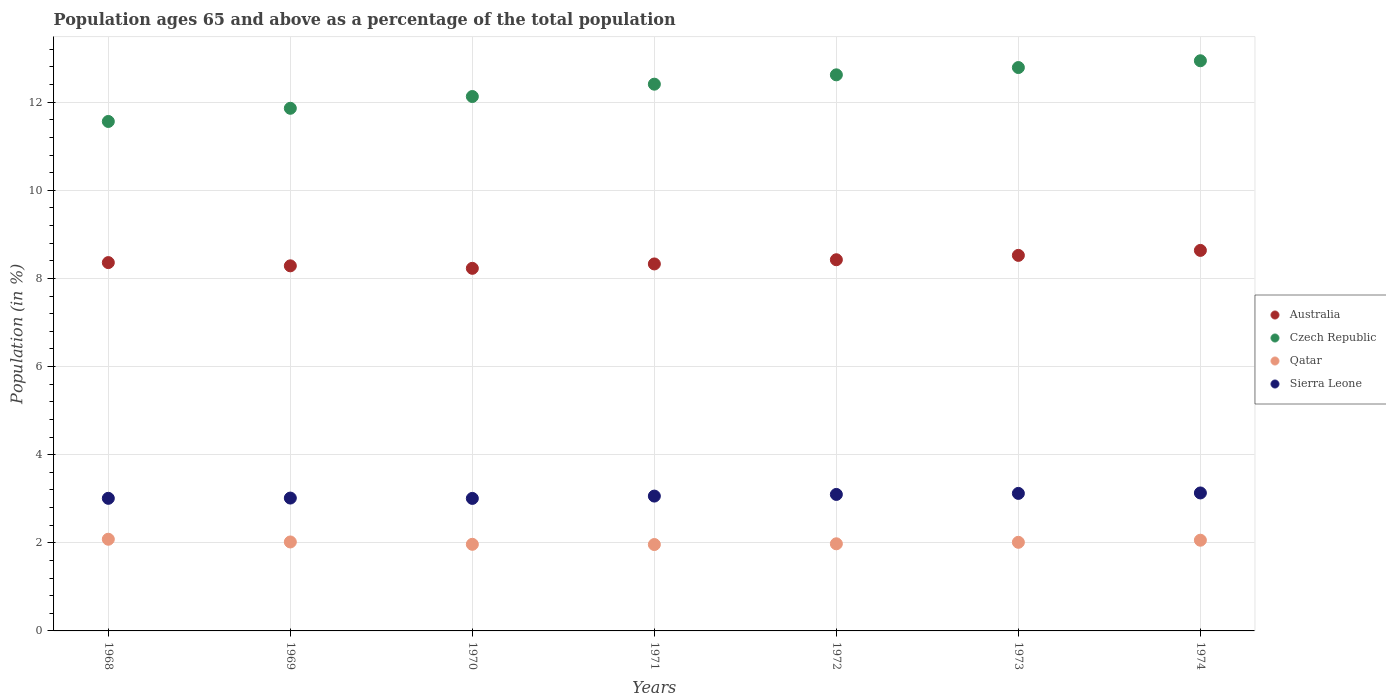Is the number of dotlines equal to the number of legend labels?
Offer a very short reply. Yes. What is the percentage of the population ages 65 and above in Sierra Leone in 1972?
Offer a terse response. 3.1. Across all years, what is the maximum percentage of the population ages 65 and above in Qatar?
Offer a terse response. 2.08. Across all years, what is the minimum percentage of the population ages 65 and above in Czech Republic?
Provide a succinct answer. 11.56. In which year was the percentage of the population ages 65 and above in Qatar maximum?
Provide a succinct answer. 1968. In which year was the percentage of the population ages 65 and above in Czech Republic minimum?
Offer a terse response. 1968. What is the total percentage of the population ages 65 and above in Sierra Leone in the graph?
Offer a very short reply. 21.44. What is the difference between the percentage of the population ages 65 and above in Australia in 1969 and that in 1973?
Your response must be concise. -0.24. What is the difference between the percentage of the population ages 65 and above in Qatar in 1972 and the percentage of the population ages 65 and above in Australia in 1968?
Make the answer very short. -6.38. What is the average percentage of the population ages 65 and above in Qatar per year?
Make the answer very short. 2.01. In the year 1968, what is the difference between the percentage of the population ages 65 and above in Qatar and percentage of the population ages 65 and above in Australia?
Your response must be concise. -6.28. In how many years, is the percentage of the population ages 65 and above in Sierra Leone greater than 11.2?
Offer a terse response. 0. What is the ratio of the percentage of the population ages 65 and above in Sierra Leone in 1968 to that in 1973?
Your response must be concise. 0.96. Is the percentage of the population ages 65 and above in Qatar in 1971 less than that in 1972?
Make the answer very short. Yes. Is the difference between the percentage of the population ages 65 and above in Qatar in 1969 and 1972 greater than the difference between the percentage of the population ages 65 and above in Australia in 1969 and 1972?
Your answer should be very brief. Yes. What is the difference between the highest and the second highest percentage of the population ages 65 and above in Australia?
Provide a short and direct response. 0.11. What is the difference between the highest and the lowest percentage of the population ages 65 and above in Qatar?
Offer a very short reply. 0.12. In how many years, is the percentage of the population ages 65 and above in Australia greater than the average percentage of the population ages 65 and above in Australia taken over all years?
Provide a short and direct response. 3. Is it the case that in every year, the sum of the percentage of the population ages 65 and above in Czech Republic and percentage of the population ages 65 and above in Qatar  is greater than the sum of percentage of the population ages 65 and above in Australia and percentage of the population ages 65 and above in Sierra Leone?
Your answer should be compact. No. Is it the case that in every year, the sum of the percentage of the population ages 65 and above in Sierra Leone and percentage of the population ages 65 and above in Qatar  is greater than the percentage of the population ages 65 and above in Czech Republic?
Your response must be concise. No. Does the percentage of the population ages 65 and above in Qatar monotonically increase over the years?
Your answer should be very brief. No. Does the graph contain any zero values?
Your answer should be compact. No. How many legend labels are there?
Give a very brief answer. 4. How are the legend labels stacked?
Provide a succinct answer. Vertical. What is the title of the graph?
Make the answer very short. Population ages 65 and above as a percentage of the total population. Does "Latin America(all income levels)" appear as one of the legend labels in the graph?
Offer a terse response. No. What is the Population (in %) in Australia in 1968?
Give a very brief answer. 8.36. What is the Population (in %) of Czech Republic in 1968?
Ensure brevity in your answer.  11.56. What is the Population (in %) in Qatar in 1968?
Your answer should be compact. 2.08. What is the Population (in %) in Sierra Leone in 1968?
Give a very brief answer. 3.01. What is the Population (in %) of Australia in 1969?
Ensure brevity in your answer.  8.29. What is the Population (in %) in Czech Republic in 1969?
Your response must be concise. 11.86. What is the Population (in %) in Qatar in 1969?
Keep it short and to the point. 2.02. What is the Population (in %) in Sierra Leone in 1969?
Your answer should be very brief. 3.02. What is the Population (in %) in Australia in 1970?
Your response must be concise. 8.23. What is the Population (in %) of Czech Republic in 1970?
Keep it short and to the point. 12.13. What is the Population (in %) of Qatar in 1970?
Your response must be concise. 1.97. What is the Population (in %) in Sierra Leone in 1970?
Make the answer very short. 3.01. What is the Population (in %) in Australia in 1971?
Offer a terse response. 8.33. What is the Population (in %) of Czech Republic in 1971?
Keep it short and to the point. 12.41. What is the Population (in %) in Qatar in 1971?
Your answer should be compact. 1.96. What is the Population (in %) of Sierra Leone in 1971?
Make the answer very short. 3.06. What is the Population (in %) in Australia in 1972?
Make the answer very short. 8.42. What is the Population (in %) in Czech Republic in 1972?
Give a very brief answer. 12.62. What is the Population (in %) in Qatar in 1972?
Your answer should be compact. 1.98. What is the Population (in %) in Sierra Leone in 1972?
Ensure brevity in your answer.  3.1. What is the Population (in %) in Australia in 1973?
Give a very brief answer. 8.52. What is the Population (in %) of Czech Republic in 1973?
Keep it short and to the point. 12.79. What is the Population (in %) in Qatar in 1973?
Ensure brevity in your answer.  2.01. What is the Population (in %) in Sierra Leone in 1973?
Ensure brevity in your answer.  3.12. What is the Population (in %) of Australia in 1974?
Offer a very short reply. 8.64. What is the Population (in %) in Czech Republic in 1974?
Your answer should be very brief. 12.94. What is the Population (in %) in Qatar in 1974?
Your answer should be compact. 2.06. What is the Population (in %) of Sierra Leone in 1974?
Your response must be concise. 3.13. Across all years, what is the maximum Population (in %) of Australia?
Give a very brief answer. 8.64. Across all years, what is the maximum Population (in %) of Czech Republic?
Give a very brief answer. 12.94. Across all years, what is the maximum Population (in %) in Qatar?
Provide a short and direct response. 2.08. Across all years, what is the maximum Population (in %) of Sierra Leone?
Give a very brief answer. 3.13. Across all years, what is the minimum Population (in %) of Australia?
Give a very brief answer. 8.23. Across all years, what is the minimum Population (in %) in Czech Republic?
Your answer should be very brief. 11.56. Across all years, what is the minimum Population (in %) in Qatar?
Your answer should be compact. 1.96. Across all years, what is the minimum Population (in %) in Sierra Leone?
Provide a succinct answer. 3.01. What is the total Population (in %) in Australia in the graph?
Make the answer very short. 58.79. What is the total Population (in %) of Czech Republic in the graph?
Offer a very short reply. 86.31. What is the total Population (in %) in Qatar in the graph?
Offer a very short reply. 14.07. What is the total Population (in %) in Sierra Leone in the graph?
Your answer should be very brief. 21.44. What is the difference between the Population (in %) in Australia in 1968 and that in 1969?
Ensure brevity in your answer.  0.07. What is the difference between the Population (in %) in Czech Republic in 1968 and that in 1969?
Your answer should be very brief. -0.3. What is the difference between the Population (in %) in Qatar in 1968 and that in 1969?
Your answer should be very brief. 0.06. What is the difference between the Population (in %) in Sierra Leone in 1968 and that in 1969?
Make the answer very short. -0.01. What is the difference between the Population (in %) of Australia in 1968 and that in 1970?
Make the answer very short. 0.13. What is the difference between the Population (in %) in Czech Republic in 1968 and that in 1970?
Provide a succinct answer. -0.57. What is the difference between the Population (in %) in Qatar in 1968 and that in 1970?
Provide a short and direct response. 0.12. What is the difference between the Population (in %) in Sierra Leone in 1968 and that in 1970?
Offer a very short reply. 0. What is the difference between the Population (in %) in Australia in 1968 and that in 1971?
Offer a very short reply. 0.03. What is the difference between the Population (in %) of Czech Republic in 1968 and that in 1971?
Your response must be concise. -0.85. What is the difference between the Population (in %) of Qatar in 1968 and that in 1971?
Provide a short and direct response. 0.12. What is the difference between the Population (in %) of Sierra Leone in 1968 and that in 1971?
Give a very brief answer. -0.05. What is the difference between the Population (in %) in Australia in 1968 and that in 1972?
Make the answer very short. -0.06. What is the difference between the Population (in %) of Czech Republic in 1968 and that in 1972?
Your answer should be very brief. -1.06. What is the difference between the Population (in %) of Qatar in 1968 and that in 1972?
Your response must be concise. 0.1. What is the difference between the Population (in %) in Sierra Leone in 1968 and that in 1972?
Give a very brief answer. -0.09. What is the difference between the Population (in %) of Australia in 1968 and that in 1973?
Provide a succinct answer. -0.16. What is the difference between the Population (in %) in Czech Republic in 1968 and that in 1973?
Keep it short and to the point. -1.22. What is the difference between the Population (in %) of Qatar in 1968 and that in 1973?
Make the answer very short. 0.07. What is the difference between the Population (in %) of Sierra Leone in 1968 and that in 1973?
Your answer should be very brief. -0.11. What is the difference between the Population (in %) in Australia in 1968 and that in 1974?
Give a very brief answer. -0.28. What is the difference between the Population (in %) in Czech Republic in 1968 and that in 1974?
Provide a succinct answer. -1.38. What is the difference between the Population (in %) of Qatar in 1968 and that in 1974?
Offer a very short reply. 0.02. What is the difference between the Population (in %) in Sierra Leone in 1968 and that in 1974?
Keep it short and to the point. -0.12. What is the difference between the Population (in %) in Australia in 1969 and that in 1970?
Make the answer very short. 0.06. What is the difference between the Population (in %) in Czech Republic in 1969 and that in 1970?
Your answer should be very brief. -0.27. What is the difference between the Population (in %) of Qatar in 1969 and that in 1970?
Make the answer very short. 0.05. What is the difference between the Population (in %) of Sierra Leone in 1969 and that in 1970?
Your answer should be very brief. 0.01. What is the difference between the Population (in %) in Australia in 1969 and that in 1971?
Make the answer very short. -0.04. What is the difference between the Population (in %) of Czech Republic in 1969 and that in 1971?
Keep it short and to the point. -0.55. What is the difference between the Population (in %) of Qatar in 1969 and that in 1971?
Keep it short and to the point. 0.06. What is the difference between the Population (in %) of Sierra Leone in 1969 and that in 1971?
Provide a succinct answer. -0.04. What is the difference between the Population (in %) of Australia in 1969 and that in 1972?
Offer a very short reply. -0.14. What is the difference between the Population (in %) of Czech Republic in 1969 and that in 1972?
Offer a very short reply. -0.76. What is the difference between the Population (in %) in Qatar in 1969 and that in 1972?
Your answer should be very brief. 0.04. What is the difference between the Population (in %) of Sierra Leone in 1969 and that in 1972?
Give a very brief answer. -0.08. What is the difference between the Population (in %) of Australia in 1969 and that in 1973?
Your answer should be very brief. -0.24. What is the difference between the Population (in %) of Czech Republic in 1969 and that in 1973?
Make the answer very short. -0.93. What is the difference between the Population (in %) of Qatar in 1969 and that in 1973?
Ensure brevity in your answer.  0.01. What is the difference between the Population (in %) of Sierra Leone in 1969 and that in 1973?
Keep it short and to the point. -0.11. What is the difference between the Population (in %) of Australia in 1969 and that in 1974?
Ensure brevity in your answer.  -0.35. What is the difference between the Population (in %) of Czech Republic in 1969 and that in 1974?
Provide a succinct answer. -1.08. What is the difference between the Population (in %) of Qatar in 1969 and that in 1974?
Offer a terse response. -0.04. What is the difference between the Population (in %) of Sierra Leone in 1969 and that in 1974?
Offer a very short reply. -0.12. What is the difference between the Population (in %) in Australia in 1970 and that in 1971?
Make the answer very short. -0.1. What is the difference between the Population (in %) in Czech Republic in 1970 and that in 1971?
Offer a terse response. -0.28. What is the difference between the Population (in %) in Qatar in 1970 and that in 1971?
Offer a very short reply. 0.01. What is the difference between the Population (in %) of Sierra Leone in 1970 and that in 1971?
Provide a short and direct response. -0.05. What is the difference between the Population (in %) of Australia in 1970 and that in 1972?
Offer a terse response. -0.2. What is the difference between the Population (in %) in Czech Republic in 1970 and that in 1972?
Your answer should be very brief. -0.49. What is the difference between the Population (in %) in Qatar in 1970 and that in 1972?
Make the answer very short. -0.01. What is the difference between the Population (in %) of Sierra Leone in 1970 and that in 1972?
Give a very brief answer. -0.09. What is the difference between the Population (in %) of Australia in 1970 and that in 1973?
Make the answer very short. -0.29. What is the difference between the Population (in %) of Czech Republic in 1970 and that in 1973?
Offer a very short reply. -0.66. What is the difference between the Population (in %) in Qatar in 1970 and that in 1973?
Ensure brevity in your answer.  -0.05. What is the difference between the Population (in %) of Sierra Leone in 1970 and that in 1973?
Offer a terse response. -0.11. What is the difference between the Population (in %) of Australia in 1970 and that in 1974?
Offer a terse response. -0.41. What is the difference between the Population (in %) of Czech Republic in 1970 and that in 1974?
Your answer should be compact. -0.81. What is the difference between the Population (in %) in Qatar in 1970 and that in 1974?
Your answer should be compact. -0.09. What is the difference between the Population (in %) of Sierra Leone in 1970 and that in 1974?
Your response must be concise. -0.12. What is the difference between the Population (in %) in Australia in 1971 and that in 1972?
Ensure brevity in your answer.  -0.1. What is the difference between the Population (in %) in Czech Republic in 1971 and that in 1972?
Make the answer very short. -0.21. What is the difference between the Population (in %) in Qatar in 1971 and that in 1972?
Offer a very short reply. -0.02. What is the difference between the Population (in %) of Sierra Leone in 1971 and that in 1972?
Make the answer very short. -0.04. What is the difference between the Population (in %) in Australia in 1971 and that in 1973?
Give a very brief answer. -0.19. What is the difference between the Population (in %) in Czech Republic in 1971 and that in 1973?
Give a very brief answer. -0.38. What is the difference between the Population (in %) of Qatar in 1971 and that in 1973?
Offer a very short reply. -0.05. What is the difference between the Population (in %) of Sierra Leone in 1971 and that in 1973?
Ensure brevity in your answer.  -0.06. What is the difference between the Population (in %) in Australia in 1971 and that in 1974?
Provide a short and direct response. -0.31. What is the difference between the Population (in %) in Czech Republic in 1971 and that in 1974?
Your answer should be compact. -0.53. What is the difference between the Population (in %) in Qatar in 1971 and that in 1974?
Your answer should be very brief. -0.1. What is the difference between the Population (in %) of Sierra Leone in 1971 and that in 1974?
Your answer should be compact. -0.07. What is the difference between the Population (in %) in Australia in 1972 and that in 1973?
Keep it short and to the point. -0.1. What is the difference between the Population (in %) of Czech Republic in 1972 and that in 1973?
Provide a succinct answer. -0.17. What is the difference between the Population (in %) in Qatar in 1972 and that in 1973?
Ensure brevity in your answer.  -0.03. What is the difference between the Population (in %) of Sierra Leone in 1972 and that in 1973?
Ensure brevity in your answer.  -0.02. What is the difference between the Population (in %) of Australia in 1972 and that in 1974?
Offer a very short reply. -0.21. What is the difference between the Population (in %) of Czech Republic in 1972 and that in 1974?
Ensure brevity in your answer.  -0.32. What is the difference between the Population (in %) in Qatar in 1972 and that in 1974?
Make the answer very short. -0.08. What is the difference between the Population (in %) in Sierra Leone in 1972 and that in 1974?
Ensure brevity in your answer.  -0.03. What is the difference between the Population (in %) in Australia in 1973 and that in 1974?
Make the answer very short. -0.11. What is the difference between the Population (in %) in Czech Republic in 1973 and that in 1974?
Your answer should be very brief. -0.15. What is the difference between the Population (in %) of Qatar in 1973 and that in 1974?
Your response must be concise. -0.05. What is the difference between the Population (in %) in Sierra Leone in 1973 and that in 1974?
Your answer should be compact. -0.01. What is the difference between the Population (in %) in Australia in 1968 and the Population (in %) in Czech Republic in 1969?
Give a very brief answer. -3.5. What is the difference between the Population (in %) in Australia in 1968 and the Population (in %) in Qatar in 1969?
Your response must be concise. 6.34. What is the difference between the Population (in %) in Australia in 1968 and the Population (in %) in Sierra Leone in 1969?
Provide a succinct answer. 5.34. What is the difference between the Population (in %) in Czech Republic in 1968 and the Population (in %) in Qatar in 1969?
Offer a terse response. 9.54. What is the difference between the Population (in %) of Czech Republic in 1968 and the Population (in %) of Sierra Leone in 1969?
Offer a very short reply. 8.55. What is the difference between the Population (in %) of Qatar in 1968 and the Population (in %) of Sierra Leone in 1969?
Keep it short and to the point. -0.93. What is the difference between the Population (in %) of Australia in 1968 and the Population (in %) of Czech Republic in 1970?
Offer a terse response. -3.77. What is the difference between the Population (in %) of Australia in 1968 and the Population (in %) of Qatar in 1970?
Provide a short and direct response. 6.39. What is the difference between the Population (in %) in Australia in 1968 and the Population (in %) in Sierra Leone in 1970?
Your answer should be very brief. 5.35. What is the difference between the Population (in %) of Czech Republic in 1968 and the Population (in %) of Qatar in 1970?
Ensure brevity in your answer.  9.6. What is the difference between the Population (in %) in Czech Republic in 1968 and the Population (in %) in Sierra Leone in 1970?
Provide a succinct answer. 8.55. What is the difference between the Population (in %) of Qatar in 1968 and the Population (in %) of Sierra Leone in 1970?
Keep it short and to the point. -0.93. What is the difference between the Population (in %) of Australia in 1968 and the Population (in %) of Czech Republic in 1971?
Your answer should be very brief. -4.05. What is the difference between the Population (in %) in Australia in 1968 and the Population (in %) in Qatar in 1971?
Ensure brevity in your answer.  6.4. What is the difference between the Population (in %) of Australia in 1968 and the Population (in %) of Sierra Leone in 1971?
Offer a terse response. 5.3. What is the difference between the Population (in %) of Czech Republic in 1968 and the Population (in %) of Qatar in 1971?
Keep it short and to the point. 9.6. What is the difference between the Population (in %) of Czech Republic in 1968 and the Population (in %) of Sierra Leone in 1971?
Provide a succinct answer. 8.5. What is the difference between the Population (in %) of Qatar in 1968 and the Population (in %) of Sierra Leone in 1971?
Offer a terse response. -0.98. What is the difference between the Population (in %) in Australia in 1968 and the Population (in %) in Czech Republic in 1972?
Provide a short and direct response. -4.26. What is the difference between the Population (in %) in Australia in 1968 and the Population (in %) in Qatar in 1972?
Ensure brevity in your answer.  6.38. What is the difference between the Population (in %) in Australia in 1968 and the Population (in %) in Sierra Leone in 1972?
Make the answer very short. 5.26. What is the difference between the Population (in %) in Czech Republic in 1968 and the Population (in %) in Qatar in 1972?
Give a very brief answer. 9.58. What is the difference between the Population (in %) of Czech Republic in 1968 and the Population (in %) of Sierra Leone in 1972?
Offer a very short reply. 8.46. What is the difference between the Population (in %) in Qatar in 1968 and the Population (in %) in Sierra Leone in 1972?
Your answer should be very brief. -1.02. What is the difference between the Population (in %) in Australia in 1968 and the Population (in %) in Czech Republic in 1973?
Your answer should be very brief. -4.43. What is the difference between the Population (in %) in Australia in 1968 and the Population (in %) in Qatar in 1973?
Your response must be concise. 6.35. What is the difference between the Population (in %) in Australia in 1968 and the Population (in %) in Sierra Leone in 1973?
Ensure brevity in your answer.  5.24. What is the difference between the Population (in %) of Czech Republic in 1968 and the Population (in %) of Qatar in 1973?
Your answer should be compact. 9.55. What is the difference between the Population (in %) of Czech Republic in 1968 and the Population (in %) of Sierra Leone in 1973?
Your answer should be very brief. 8.44. What is the difference between the Population (in %) of Qatar in 1968 and the Population (in %) of Sierra Leone in 1973?
Make the answer very short. -1.04. What is the difference between the Population (in %) in Australia in 1968 and the Population (in %) in Czech Republic in 1974?
Your response must be concise. -4.58. What is the difference between the Population (in %) of Australia in 1968 and the Population (in %) of Qatar in 1974?
Provide a short and direct response. 6.3. What is the difference between the Population (in %) of Australia in 1968 and the Population (in %) of Sierra Leone in 1974?
Offer a very short reply. 5.23. What is the difference between the Population (in %) of Czech Republic in 1968 and the Population (in %) of Qatar in 1974?
Your answer should be very brief. 9.5. What is the difference between the Population (in %) of Czech Republic in 1968 and the Population (in %) of Sierra Leone in 1974?
Your answer should be compact. 8.43. What is the difference between the Population (in %) in Qatar in 1968 and the Population (in %) in Sierra Leone in 1974?
Your answer should be compact. -1.05. What is the difference between the Population (in %) of Australia in 1969 and the Population (in %) of Czech Republic in 1970?
Make the answer very short. -3.84. What is the difference between the Population (in %) of Australia in 1969 and the Population (in %) of Qatar in 1970?
Your answer should be very brief. 6.32. What is the difference between the Population (in %) in Australia in 1969 and the Population (in %) in Sierra Leone in 1970?
Keep it short and to the point. 5.28. What is the difference between the Population (in %) in Czech Republic in 1969 and the Population (in %) in Qatar in 1970?
Your answer should be compact. 9.9. What is the difference between the Population (in %) in Czech Republic in 1969 and the Population (in %) in Sierra Leone in 1970?
Keep it short and to the point. 8.85. What is the difference between the Population (in %) in Qatar in 1969 and the Population (in %) in Sierra Leone in 1970?
Make the answer very short. -0.99. What is the difference between the Population (in %) of Australia in 1969 and the Population (in %) of Czech Republic in 1971?
Your response must be concise. -4.12. What is the difference between the Population (in %) of Australia in 1969 and the Population (in %) of Qatar in 1971?
Provide a short and direct response. 6.33. What is the difference between the Population (in %) of Australia in 1969 and the Population (in %) of Sierra Leone in 1971?
Make the answer very short. 5.23. What is the difference between the Population (in %) of Czech Republic in 1969 and the Population (in %) of Qatar in 1971?
Ensure brevity in your answer.  9.9. What is the difference between the Population (in %) of Czech Republic in 1969 and the Population (in %) of Sierra Leone in 1971?
Keep it short and to the point. 8.8. What is the difference between the Population (in %) in Qatar in 1969 and the Population (in %) in Sierra Leone in 1971?
Ensure brevity in your answer.  -1.04. What is the difference between the Population (in %) of Australia in 1969 and the Population (in %) of Czech Republic in 1972?
Ensure brevity in your answer.  -4.33. What is the difference between the Population (in %) in Australia in 1969 and the Population (in %) in Qatar in 1972?
Provide a short and direct response. 6.31. What is the difference between the Population (in %) of Australia in 1969 and the Population (in %) of Sierra Leone in 1972?
Provide a short and direct response. 5.19. What is the difference between the Population (in %) of Czech Republic in 1969 and the Population (in %) of Qatar in 1972?
Offer a terse response. 9.88. What is the difference between the Population (in %) of Czech Republic in 1969 and the Population (in %) of Sierra Leone in 1972?
Your answer should be very brief. 8.76. What is the difference between the Population (in %) of Qatar in 1969 and the Population (in %) of Sierra Leone in 1972?
Make the answer very short. -1.08. What is the difference between the Population (in %) of Australia in 1969 and the Population (in %) of Czech Republic in 1973?
Your answer should be compact. -4.5. What is the difference between the Population (in %) in Australia in 1969 and the Population (in %) in Qatar in 1973?
Offer a very short reply. 6.27. What is the difference between the Population (in %) in Australia in 1969 and the Population (in %) in Sierra Leone in 1973?
Provide a short and direct response. 5.16. What is the difference between the Population (in %) of Czech Republic in 1969 and the Population (in %) of Qatar in 1973?
Provide a short and direct response. 9.85. What is the difference between the Population (in %) of Czech Republic in 1969 and the Population (in %) of Sierra Leone in 1973?
Provide a succinct answer. 8.74. What is the difference between the Population (in %) of Qatar in 1969 and the Population (in %) of Sierra Leone in 1973?
Your answer should be compact. -1.1. What is the difference between the Population (in %) in Australia in 1969 and the Population (in %) in Czech Republic in 1974?
Keep it short and to the point. -4.65. What is the difference between the Population (in %) in Australia in 1969 and the Population (in %) in Qatar in 1974?
Ensure brevity in your answer.  6.23. What is the difference between the Population (in %) of Australia in 1969 and the Population (in %) of Sierra Leone in 1974?
Keep it short and to the point. 5.15. What is the difference between the Population (in %) in Czech Republic in 1969 and the Population (in %) in Qatar in 1974?
Offer a very short reply. 9.8. What is the difference between the Population (in %) in Czech Republic in 1969 and the Population (in %) in Sierra Leone in 1974?
Give a very brief answer. 8.73. What is the difference between the Population (in %) in Qatar in 1969 and the Population (in %) in Sierra Leone in 1974?
Make the answer very short. -1.11. What is the difference between the Population (in %) in Australia in 1970 and the Population (in %) in Czech Republic in 1971?
Keep it short and to the point. -4.18. What is the difference between the Population (in %) of Australia in 1970 and the Population (in %) of Qatar in 1971?
Your answer should be very brief. 6.27. What is the difference between the Population (in %) in Australia in 1970 and the Population (in %) in Sierra Leone in 1971?
Offer a terse response. 5.17. What is the difference between the Population (in %) of Czech Republic in 1970 and the Population (in %) of Qatar in 1971?
Offer a very short reply. 10.17. What is the difference between the Population (in %) in Czech Republic in 1970 and the Population (in %) in Sierra Leone in 1971?
Your response must be concise. 9.07. What is the difference between the Population (in %) of Qatar in 1970 and the Population (in %) of Sierra Leone in 1971?
Ensure brevity in your answer.  -1.09. What is the difference between the Population (in %) of Australia in 1970 and the Population (in %) of Czech Republic in 1972?
Offer a very short reply. -4.39. What is the difference between the Population (in %) of Australia in 1970 and the Population (in %) of Qatar in 1972?
Ensure brevity in your answer.  6.25. What is the difference between the Population (in %) in Australia in 1970 and the Population (in %) in Sierra Leone in 1972?
Provide a succinct answer. 5.13. What is the difference between the Population (in %) of Czech Republic in 1970 and the Population (in %) of Qatar in 1972?
Provide a succinct answer. 10.15. What is the difference between the Population (in %) in Czech Republic in 1970 and the Population (in %) in Sierra Leone in 1972?
Give a very brief answer. 9.03. What is the difference between the Population (in %) in Qatar in 1970 and the Population (in %) in Sierra Leone in 1972?
Your answer should be compact. -1.13. What is the difference between the Population (in %) of Australia in 1970 and the Population (in %) of Czech Republic in 1973?
Give a very brief answer. -4.56. What is the difference between the Population (in %) in Australia in 1970 and the Population (in %) in Qatar in 1973?
Ensure brevity in your answer.  6.22. What is the difference between the Population (in %) in Australia in 1970 and the Population (in %) in Sierra Leone in 1973?
Ensure brevity in your answer.  5.11. What is the difference between the Population (in %) in Czech Republic in 1970 and the Population (in %) in Qatar in 1973?
Provide a short and direct response. 10.12. What is the difference between the Population (in %) of Czech Republic in 1970 and the Population (in %) of Sierra Leone in 1973?
Keep it short and to the point. 9.01. What is the difference between the Population (in %) in Qatar in 1970 and the Population (in %) in Sierra Leone in 1973?
Offer a terse response. -1.16. What is the difference between the Population (in %) of Australia in 1970 and the Population (in %) of Czech Republic in 1974?
Provide a short and direct response. -4.71. What is the difference between the Population (in %) of Australia in 1970 and the Population (in %) of Qatar in 1974?
Give a very brief answer. 6.17. What is the difference between the Population (in %) of Australia in 1970 and the Population (in %) of Sierra Leone in 1974?
Offer a terse response. 5.1. What is the difference between the Population (in %) in Czech Republic in 1970 and the Population (in %) in Qatar in 1974?
Provide a short and direct response. 10.07. What is the difference between the Population (in %) of Czech Republic in 1970 and the Population (in %) of Sierra Leone in 1974?
Your answer should be compact. 9. What is the difference between the Population (in %) of Qatar in 1970 and the Population (in %) of Sierra Leone in 1974?
Give a very brief answer. -1.17. What is the difference between the Population (in %) of Australia in 1971 and the Population (in %) of Czech Republic in 1972?
Provide a succinct answer. -4.29. What is the difference between the Population (in %) of Australia in 1971 and the Population (in %) of Qatar in 1972?
Your answer should be very brief. 6.35. What is the difference between the Population (in %) of Australia in 1971 and the Population (in %) of Sierra Leone in 1972?
Ensure brevity in your answer.  5.23. What is the difference between the Population (in %) of Czech Republic in 1971 and the Population (in %) of Qatar in 1972?
Offer a very short reply. 10.43. What is the difference between the Population (in %) of Czech Republic in 1971 and the Population (in %) of Sierra Leone in 1972?
Ensure brevity in your answer.  9.31. What is the difference between the Population (in %) in Qatar in 1971 and the Population (in %) in Sierra Leone in 1972?
Your response must be concise. -1.14. What is the difference between the Population (in %) in Australia in 1971 and the Population (in %) in Czech Republic in 1973?
Your response must be concise. -4.46. What is the difference between the Population (in %) in Australia in 1971 and the Population (in %) in Qatar in 1973?
Provide a succinct answer. 6.32. What is the difference between the Population (in %) in Australia in 1971 and the Population (in %) in Sierra Leone in 1973?
Keep it short and to the point. 5.21. What is the difference between the Population (in %) in Czech Republic in 1971 and the Population (in %) in Qatar in 1973?
Offer a very short reply. 10.4. What is the difference between the Population (in %) in Czech Republic in 1971 and the Population (in %) in Sierra Leone in 1973?
Keep it short and to the point. 9.29. What is the difference between the Population (in %) in Qatar in 1971 and the Population (in %) in Sierra Leone in 1973?
Your response must be concise. -1.16. What is the difference between the Population (in %) in Australia in 1971 and the Population (in %) in Czech Republic in 1974?
Your answer should be very brief. -4.61. What is the difference between the Population (in %) of Australia in 1971 and the Population (in %) of Qatar in 1974?
Ensure brevity in your answer.  6.27. What is the difference between the Population (in %) in Australia in 1971 and the Population (in %) in Sierra Leone in 1974?
Your answer should be compact. 5.2. What is the difference between the Population (in %) of Czech Republic in 1971 and the Population (in %) of Qatar in 1974?
Provide a succinct answer. 10.35. What is the difference between the Population (in %) in Czech Republic in 1971 and the Population (in %) in Sierra Leone in 1974?
Give a very brief answer. 9.28. What is the difference between the Population (in %) of Qatar in 1971 and the Population (in %) of Sierra Leone in 1974?
Give a very brief answer. -1.17. What is the difference between the Population (in %) of Australia in 1972 and the Population (in %) of Czech Republic in 1973?
Offer a terse response. -4.36. What is the difference between the Population (in %) in Australia in 1972 and the Population (in %) in Qatar in 1973?
Keep it short and to the point. 6.41. What is the difference between the Population (in %) of Australia in 1972 and the Population (in %) of Sierra Leone in 1973?
Your response must be concise. 5.3. What is the difference between the Population (in %) of Czech Republic in 1972 and the Population (in %) of Qatar in 1973?
Keep it short and to the point. 10.61. What is the difference between the Population (in %) in Czech Republic in 1972 and the Population (in %) in Sierra Leone in 1973?
Keep it short and to the point. 9.5. What is the difference between the Population (in %) in Qatar in 1972 and the Population (in %) in Sierra Leone in 1973?
Your answer should be very brief. -1.14. What is the difference between the Population (in %) of Australia in 1972 and the Population (in %) of Czech Republic in 1974?
Offer a very short reply. -4.52. What is the difference between the Population (in %) of Australia in 1972 and the Population (in %) of Qatar in 1974?
Provide a short and direct response. 6.37. What is the difference between the Population (in %) in Australia in 1972 and the Population (in %) in Sierra Leone in 1974?
Your answer should be very brief. 5.29. What is the difference between the Population (in %) in Czech Republic in 1972 and the Population (in %) in Qatar in 1974?
Offer a very short reply. 10.56. What is the difference between the Population (in %) of Czech Republic in 1972 and the Population (in %) of Sierra Leone in 1974?
Ensure brevity in your answer.  9.49. What is the difference between the Population (in %) in Qatar in 1972 and the Population (in %) in Sierra Leone in 1974?
Provide a short and direct response. -1.15. What is the difference between the Population (in %) in Australia in 1973 and the Population (in %) in Czech Republic in 1974?
Your answer should be compact. -4.42. What is the difference between the Population (in %) in Australia in 1973 and the Population (in %) in Qatar in 1974?
Provide a short and direct response. 6.46. What is the difference between the Population (in %) of Australia in 1973 and the Population (in %) of Sierra Leone in 1974?
Your answer should be compact. 5.39. What is the difference between the Population (in %) of Czech Republic in 1973 and the Population (in %) of Qatar in 1974?
Offer a very short reply. 10.73. What is the difference between the Population (in %) in Czech Republic in 1973 and the Population (in %) in Sierra Leone in 1974?
Make the answer very short. 9.65. What is the difference between the Population (in %) in Qatar in 1973 and the Population (in %) in Sierra Leone in 1974?
Provide a succinct answer. -1.12. What is the average Population (in %) in Australia per year?
Give a very brief answer. 8.4. What is the average Population (in %) in Czech Republic per year?
Offer a very short reply. 12.33. What is the average Population (in %) of Qatar per year?
Offer a very short reply. 2.01. What is the average Population (in %) of Sierra Leone per year?
Your response must be concise. 3.06. In the year 1968, what is the difference between the Population (in %) in Australia and Population (in %) in Czech Republic?
Offer a terse response. -3.2. In the year 1968, what is the difference between the Population (in %) of Australia and Population (in %) of Qatar?
Make the answer very short. 6.28. In the year 1968, what is the difference between the Population (in %) of Australia and Population (in %) of Sierra Leone?
Your response must be concise. 5.35. In the year 1968, what is the difference between the Population (in %) in Czech Republic and Population (in %) in Qatar?
Provide a succinct answer. 9.48. In the year 1968, what is the difference between the Population (in %) of Czech Republic and Population (in %) of Sierra Leone?
Keep it short and to the point. 8.55. In the year 1968, what is the difference between the Population (in %) of Qatar and Population (in %) of Sierra Leone?
Your response must be concise. -0.93. In the year 1969, what is the difference between the Population (in %) in Australia and Population (in %) in Czech Republic?
Your response must be concise. -3.58. In the year 1969, what is the difference between the Population (in %) of Australia and Population (in %) of Qatar?
Keep it short and to the point. 6.27. In the year 1969, what is the difference between the Population (in %) of Australia and Population (in %) of Sierra Leone?
Ensure brevity in your answer.  5.27. In the year 1969, what is the difference between the Population (in %) in Czech Republic and Population (in %) in Qatar?
Your answer should be very brief. 9.84. In the year 1969, what is the difference between the Population (in %) in Czech Republic and Population (in %) in Sierra Leone?
Provide a succinct answer. 8.85. In the year 1969, what is the difference between the Population (in %) in Qatar and Population (in %) in Sierra Leone?
Your response must be concise. -1. In the year 1970, what is the difference between the Population (in %) of Australia and Population (in %) of Czech Republic?
Offer a terse response. -3.9. In the year 1970, what is the difference between the Population (in %) of Australia and Population (in %) of Qatar?
Give a very brief answer. 6.26. In the year 1970, what is the difference between the Population (in %) of Australia and Population (in %) of Sierra Leone?
Your response must be concise. 5.22. In the year 1970, what is the difference between the Population (in %) of Czech Republic and Population (in %) of Qatar?
Ensure brevity in your answer.  10.16. In the year 1970, what is the difference between the Population (in %) of Czech Republic and Population (in %) of Sierra Leone?
Ensure brevity in your answer.  9.12. In the year 1970, what is the difference between the Population (in %) of Qatar and Population (in %) of Sierra Leone?
Your response must be concise. -1.04. In the year 1971, what is the difference between the Population (in %) in Australia and Population (in %) in Czech Republic?
Ensure brevity in your answer.  -4.08. In the year 1971, what is the difference between the Population (in %) of Australia and Population (in %) of Qatar?
Provide a short and direct response. 6.37. In the year 1971, what is the difference between the Population (in %) of Australia and Population (in %) of Sierra Leone?
Offer a very short reply. 5.27. In the year 1971, what is the difference between the Population (in %) in Czech Republic and Population (in %) in Qatar?
Ensure brevity in your answer.  10.45. In the year 1971, what is the difference between the Population (in %) of Czech Republic and Population (in %) of Sierra Leone?
Ensure brevity in your answer.  9.35. In the year 1971, what is the difference between the Population (in %) of Qatar and Population (in %) of Sierra Leone?
Ensure brevity in your answer.  -1.1. In the year 1972, what is the difference between the Population (in %) of Australia and Population (in %) of Czech Republic?
Make the answer very short. -4.2. In the year 1972, what is the difference between the Population (in %) in Australia and Population (in %) in Qatar?
Give a very brief answer. 6.45. In the year 1972, what is the difference between the Population (in %) in Australia and Population (in %) in Sierra Leone?
Give a very brief answer. 5.33. In the year 1972, what is the difference between the Population (in %) of Czech Republic and Population (in %) of Qatar?
Provide a short and direct response. 10.64. In the year 1972, what is the difference between the Population (in %) in Czech Republic and Population (in %) in Sierra Leone?
Provide a succinct answer. 9.52. In the year 1972, what is the difference between the Population (in %) of Qatar and Population (in %) of Sierra Leone?
Offer a terse response. -1.12. In the year 1973, what is the difference between the Population (in %) of Australia and Population (in %) of Czech Republic?
Your answer should be very brief. -4.26. In the year 1973, what is the difference between the Population (in %) in Australia and Population (in %) in Qatar?
Your answer should be very brief. 6.51. In the year 1973, what is the difference between the Population (in %) of Australia and Population (in %) of Sierra Leone?
Your answer should be compact. 5.4. In the year 1973, what is the difference between the Population (in %) in Czech Republic and Population (in %) in Qatar?
Keep it short and to the point. 10.78. In the year 1973, what is the difference between the Population (in %) of Czech Republic and Population (in %) of Sierra Leone?
Offer a terse response. 9.66. In the year 1973, what is the difference between the Population (in %) of Qatar and Population (in %) of Sierra Leone?
Your answer should be very brief. -1.11. In the year 1974, what is the difference between the Population (in %) of Australia and Population (in %) of Czech Republic?
Provide a short and direct response. -4.3. In the year 1974, what is the difference between the Population (in %) in Australia and Population (in %) in Qatar?
Provide a succinct answer. 6.58. In the year 1974, what is the difference between the Population (in %) of Australia and Population (in %) of Sierra Leone?
Provide a succinct answer. 5.5. In the year 1974, what is the difference between the Population (in %) of Czech Republic and Population (in %) of Qatar?
Your answer should be very brief. 10.88. In the year 1974, what is the difference between the Population (in %) in Czech Republic and Population (in %) in Sierra Leone?
Provide a succinct answer. 9.81. In the year 1974, what is the difference between the Population (in %) in Qatar and Population (in %) in Sierra Leone?
Your response must be concise. -1.07. What is the ratio of the Population (in %) in Australia in 1968 to that in 1969?
Your answer should be compact. 1.01. What is the ratio of the Population (in %) of Czech Republic in 1968 to that in 1969?
Offer a very short reply. 0.97. What is the ratio of the Population (in %) of Qatar in 1968 to that in 1969?
Offer a very short reply. 1.03. What is the ratio of the Population (in %) in Australia in 1968 to that in 1970?
Your answer should be compact. 1.02. What is the ratio of the Population (in %) of Czech Republic in 1968 to that in 1970?
Offer a very short reply. 0.95. What is the ratio of the Population (in %) in Qatar in 1968 to that in 1970?
Your answer should be very brief. 1.06. What is the ratio of the Population (in %) in Australia in 1968 to that in 1971?
Provide a short and direct response. 1. What is the ratio of the Population (in %) of Czech Republic in 1968 to that in 1971?
Keep it short and to the point. 0.93. What is the ratio of the Population (in %) in Qatar in 1968 to that in 1971?
Give a very brief answer. 1.06. What is the ratio of the Population (in %) in Sierra Leone in 1968 to that in 1971?
Your answer should be compact. 0.98. What is the ratio of the Population (in %) of Australia in 1968 to that in 1972?
Give a very brief answer. 0.99. What is the ratio of the Population (in %) of Czech Republic in 1968 to that in 1972?
Your response must be concise. 0.92. What is the ratio of the Population (in %) in Qatar in 1968 to that in 1972?
Offer a very short reply. 1.05. What is the ratio of the Population (in %) in Sierra Leone in 1968 to that in 1972?
Offer a very short reply. 0.97. What is the ratio of the Population (in %) of Australia in 1968 to that in 1973?
Provide a succinct answer. 0.98. What is the ratio of the Population (in %) in Czech Republic in 1968 to that in 1973?
Make the answer very short. 0.9. What is the ratio of the Population (in %) in Qatar in 1968 to that in 1973?
Your answer should be very brief. 1.03. What is the ratio of the Population (in %) in Sierra Leone in 1968 to that in 1973?
Make the answer very short. 0.96. What is the ratio of the Population (in %) of Czech Republic in 1968 to that in 1974?
Provide a succinct answer. 0.89. What is the ratio of the Population (in %) of Qatar in 1968 to that in 1974?
Provide a short and direct response. 1.01. What is the ratio of the Population (in %) of Sierra Leone in 1968 to that in 1974?
Provide a succinct answer. 0.96. What is the ratio of the Population (in %) in Czech Republic in 1969 to that in 1970?
Provide a short and direct response. 0.98. What is the ratio of the Population (in %) of Qatar in 1969 to that in 1970?
Offer a terse response. 1.03. What is the ratio of the Population (in %) in Sierra Leone in 1969 to that in 1970?
Your answer should be very brief. 1. What is the ratio of the Population (in %) of Czech Republic in 1969 to that in 1971?
Your answer should be very brief. 0.96. What is the ratio of the Population (in %) in Qatar in 1969 to that in 1971?
Offer a very short reply. 1.03. What is the ratio of the Population (in %) in Sierra Leone in 1969 to that in 1971?
Keep it short and to the point. 0.99. What is the ratio of the Population (in %) of Australia in 1969 to that in 1972?
Keep it short and to the point. 0.98. What is the ratio of the Population (in %) of Czech Republic in 1969 to that in 1972?
Offer a very short reply. 0.94. What is the ratio of the Population (in %) in Qatar in 1969 to that in 1972?
Your response must be concise. 1.02. What is the ratio of the Population (in %) in Sierra Leone in 1969 to that in 1972?
Make the answer very short. 0.97. What is the ratio of the Population (in %) in Australia in 1969 to that in 1973?
Ensure brevity in your answer.  0.97. What is the ratio of the Population (in %) in Czech Republic in 1969 to that in 1973?
Your answer should be very brief. 0.93. What is the ratio of the Population (in %) of Sierra Leone in 1969 to that in 1973?
Provide a short and direct response. 0.97. What is the ratio of the Population (in %) in Australia in 1969 to that in 1974?
Offer a very short reply. 0.96. What is the ratio of the Population (in %) of Czech Republic in 1969 to that in 1974?
Keep it short and to the point. 0.92. What is the ratio of the Population (in %) in Qatar in 1969 to that in 1974?
Provide a short and direct response. 0.98. What is the ratio of the Population (in %) in Czech Republic in 1970 to that in 1971?
Provide a succinct answer. 0.98. What is the ratio of the Population (in %) of Qatar in 1970 to that in 1971?
Provide a succinct answer. 1. What is the ratio of the Population (in %) in Sierra Leone in 1970 to that in 1971?
Make the answer very short. 0.98. What is the ratio of the Population (in %) of Australia in 1970 to that in 1972?
Give a very brief answer. 0.98. What is the ratio of the Population (in %) of Qatar in 1970 to that in 1972?
Offer a terse response. 0.99. What is the ratio of the Population (in %) in Sierra Leone in 1970 to that in 1972?
Provide a short and direct response. 0.97. What is the ratio of the Population (in %) in Australia in 1970 to that in 1973?
Your answer should be compact. 0.97. What is the ratio of the Population (in %) in Czech Republic in 1970 to that in 1973?
Provide a short and direct response. 0.95. What is the ratio of the Population (in %) in Qatar in 1970 to that in 1973?
Offer a terse response. 0.98. What is the ratio of the Population (in %) of Sierra Leone in 1970 to that in 1973?
Make the answer very short. 0.96. What is the ratio of the Population (in %) in Australia in 1970 to that in 1974?
Provide a short and direct response. 0.95. What is the ratio of the Population (in %) of Czech Republic in 1970 to that in 1974?
Provide a short and direct response. 0.94. What is the ratio of the Population (in %) of Qatar in 1970 to that in 1974?
Your answer should be very brief. 0.95. What is the ratio of the Population (in %) of Sierra Leone in 1970 to that in 1974?
Your answer should be very brief. 0.96. What is the ratio of the Population (in %) of Australia in 1971 to that in 1972?
Offer a very short reply. 0.99. What is the ratio of the Population (in %) in Czech Republic in 1971 to that in 1972?
Offer a very short reply. 0.98. What is the ratio of the Population (in %) in Qatar in 1971 to that in 1972?
Your response must be concise. 0.99. What is the ratio of the Population (in %) in Australia in 1971 to that in 1973?
Keep it short and to the point. 0.98. What is the ratio of the Population (in %) in Czech Republic in 1971 to that in 1973?
Provide a succinct answer. 0.97. What is the ratio of the Population (in %) in Qatar in 1971 to that in 1973?
Give a very brief answer. 0.97. What is the ratio of the Population (in %) in Sierra Leone in 1971 to that in 1973?
Provide a succinct answer. 0.98. What is the ratio of the Population (in %) in Australia in 1971 to that in 1974?
Offer a very short reply. 0.96. What is the ratio of the Population (in %) in Czech Republic in 1971 to that in 1974?
Your response must be concise. 0.96. What is the ratio of the Population (in %) of Qatar in 1971 to that in 1974?
Your answer should be very brief. 0.95. What is the ratio of the Population (in %) in Sierra Leone in 1971 to that in 1974?
Ensure brevity in your answer.  0.98. What is the ratio of the Population (in %) of Australia in 1972 to that in 1973?
Your answer should be very brief. 0.99. What is the ratio of the Population (in %) in Czech Republic in 1972 to that in 1973?
Provide a short and direct response. 0.99. What is the ratio of the Population (in %) in Qatar in 1972 to that in 1973?
Offer a very short reply. 0.98. What is the ratio of the Population (in %) of Sierra Leone in 1972 to that in 1973?
Your answer should be compact. 0.99. What is the ratio of the Population (in %) in Australia in 1972 to that in 1974?
Give a very brief answer. 0.98. What is the ratio of the Population (in %) in Czech Republic in 1972 to that in 1974?
Provide a succinct answer. 0.98. What is the ratio of the Population (in %) in Qatar in 1972 to that in 1974?
Your answer should be compact. 0.96. What is the ratio of the Population (in %) in Sierra Leone in 1972 to that in 1974?
Provide a succinct answer. 0.99. What is the ratio of the Population (in %) in Australia in 1973 to that in 1974?
Ensure brevity in your answer.  0.99. What is the ratio of the Population (in %) of Qatar in 1973 to that in 1974?
Your answer should be very brief. 0.98. What is the difference between the highest and the second highest Population (in %) in Australia?
Provide a short and direct response. 0.11. What is the difference between the highest and the second highest Population (in %) in Czech Republic?
Keep it short and to the point. 0.15. What is the difference between the highest and the second highest Population (in %) in Qatar?
Your response must be concise. 0.02. What is the difference between the highest and the second highest Population (in %) of Sierra Leone?
Provide a succinct answer. 0.01. What is the difference between the highest and the lowest Population (in %) of Australia?
Your response must be concise. 0.41. What is the difference between the highest and the lowest Population (in %) in Czech Republic?
Provide a succinct answer. 1.38. What is the difference between the highest and the lowest Population (in %) of Qatar?
Provide a succinct answer. 0.12. What is the difference between the highest and the lowest Population (in %) of Sierra Leone?
Provide a short and direct response. 0.12. 